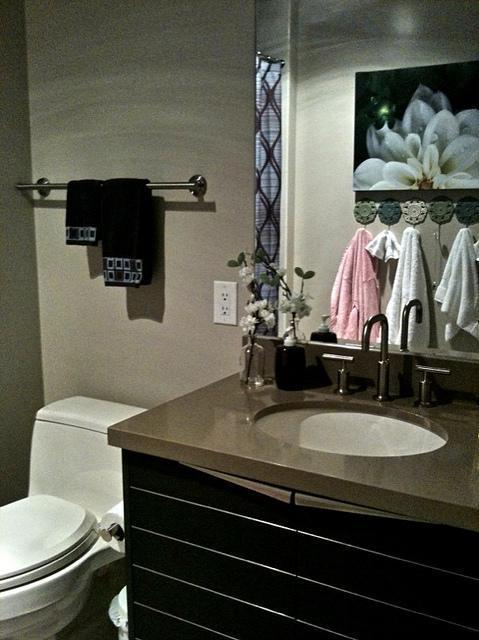How many towels are visible?
Give a very brief answer. 5. How many hand towels do you see?
Give a very brief answer. 5. 